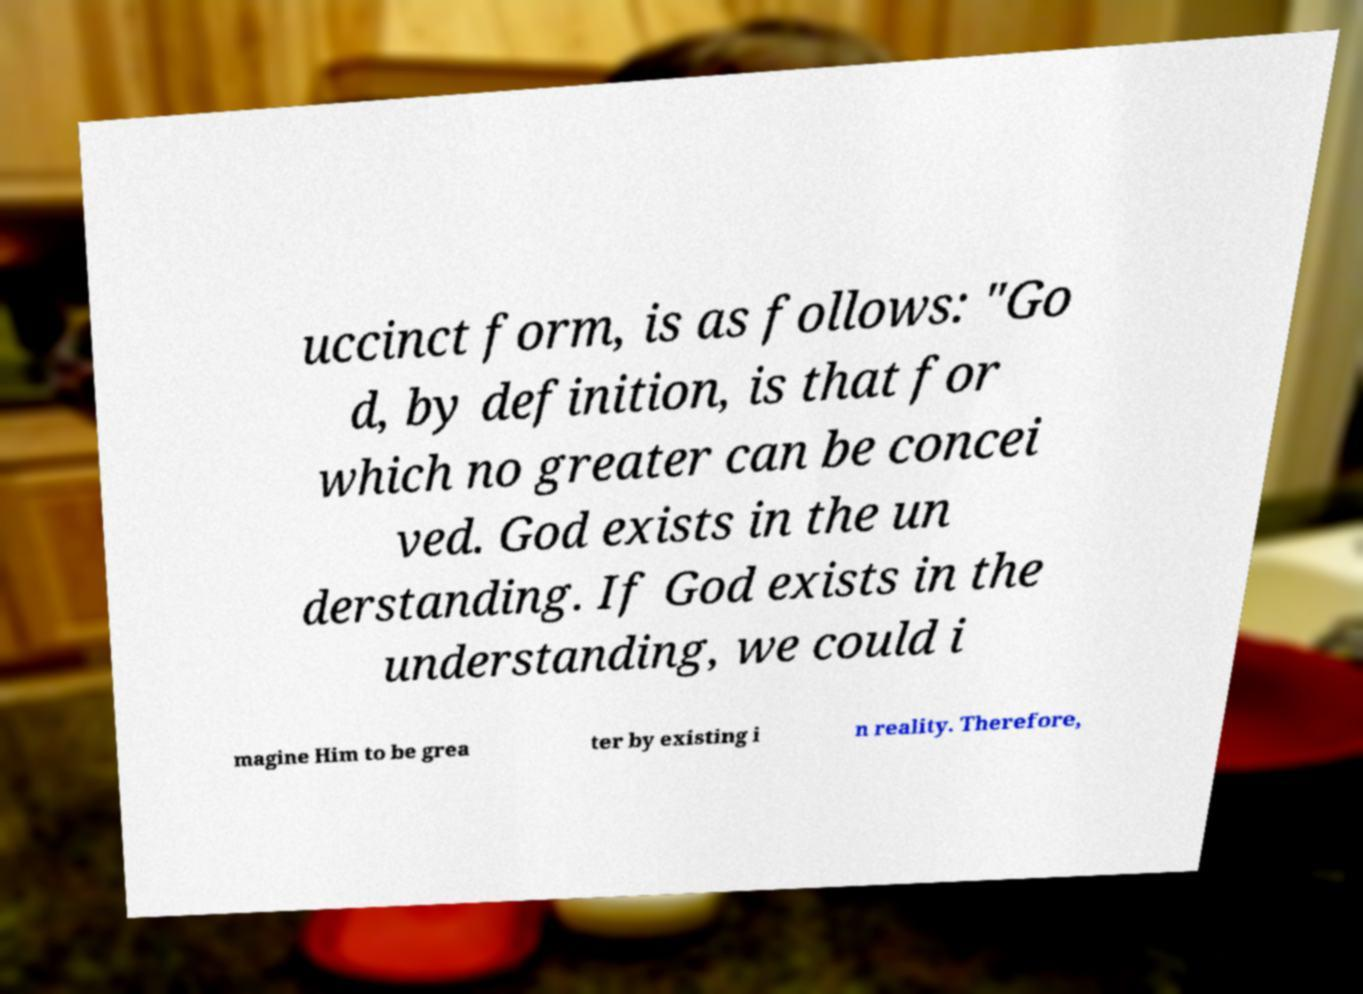Can you read and provide the text displayed in the image?This photo seems to have some interesting text. Can you extract and type it out for me? uccinct form, is as follows: "Go d, by definition, is that for which no greater can be concei ved. God exists in the un derstanding. If God exists in the understanding, we could i magine Him to be grea ter by existing i n reality. Therefore, 